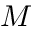Convert formula to latex. <formula><loc_0><loc_0><loc_500><loc_500>M</formula> 